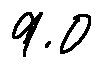<formula> <loc_0><loc_0><loc_500><loc_500>9 . 0</formula> 